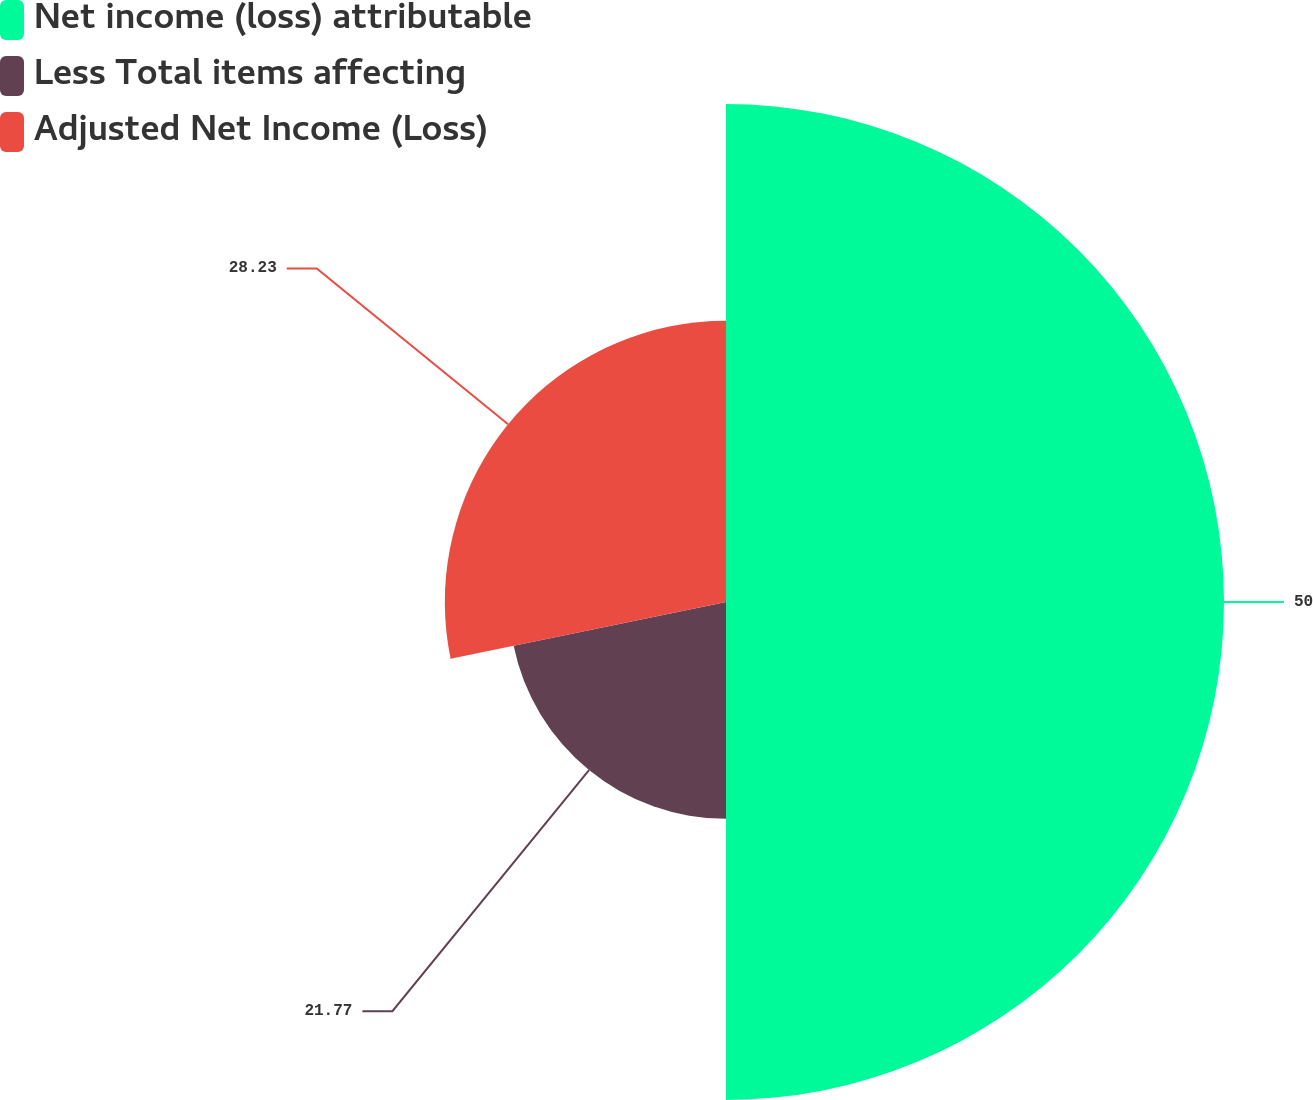Convert chart. <chart><loc_0><loc_0><loc_500><loc_500><pie_chart><fcel>Net income (loss) attributable<fcel>Less Total items affecting<fcel>Adjusted Net Income (Loss)<nl><fcel>50.0%<fcel>21.77%<fcel>28.23%<nl></chart> 